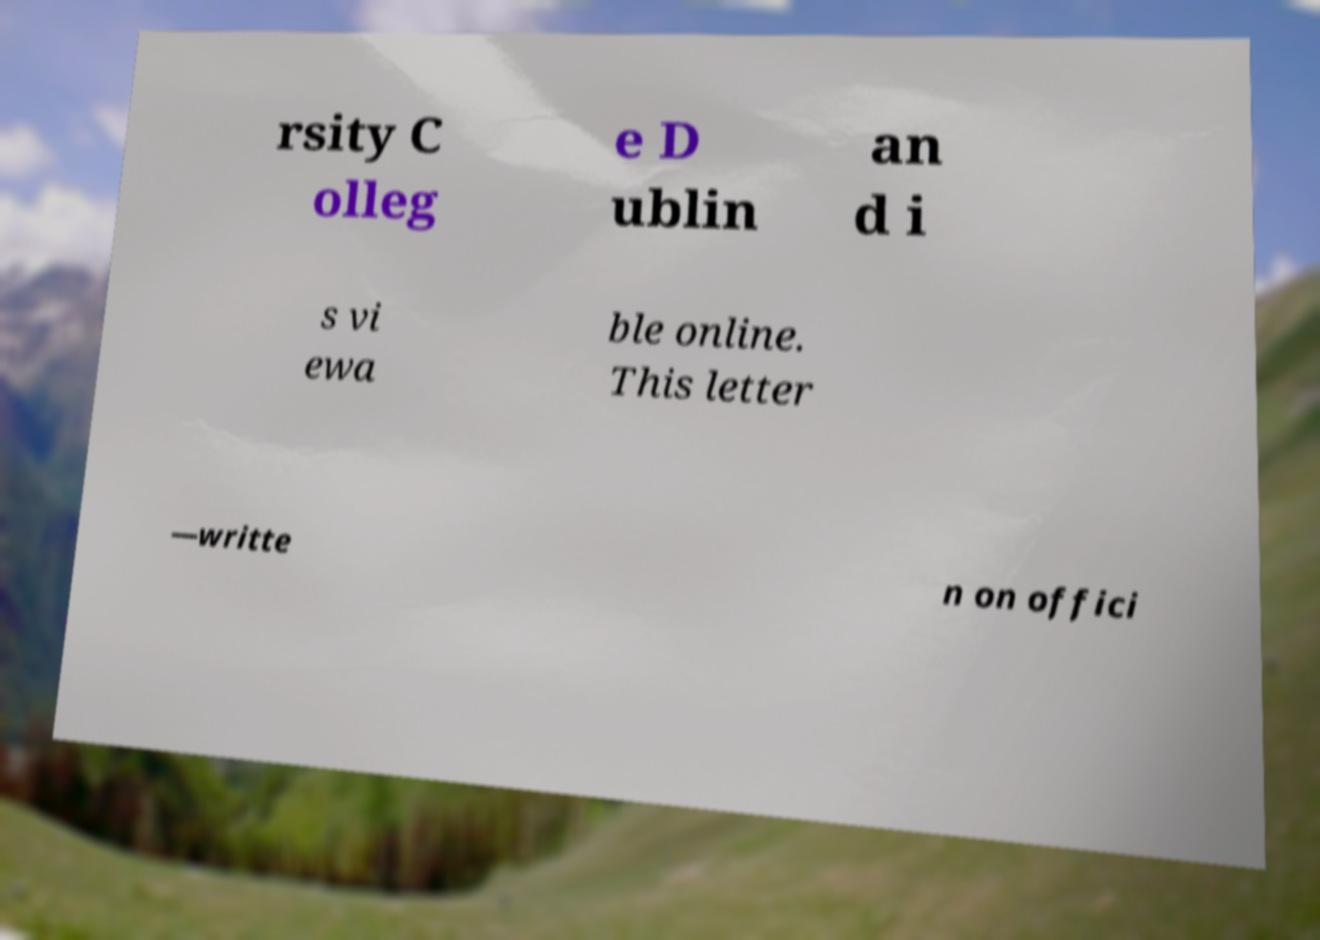For documentation purposes, I need the text within this image transcribed. Could you provide that? rsity C olleg e D ublin an d i s vi ewa ble online. This letter —writte n on offici 